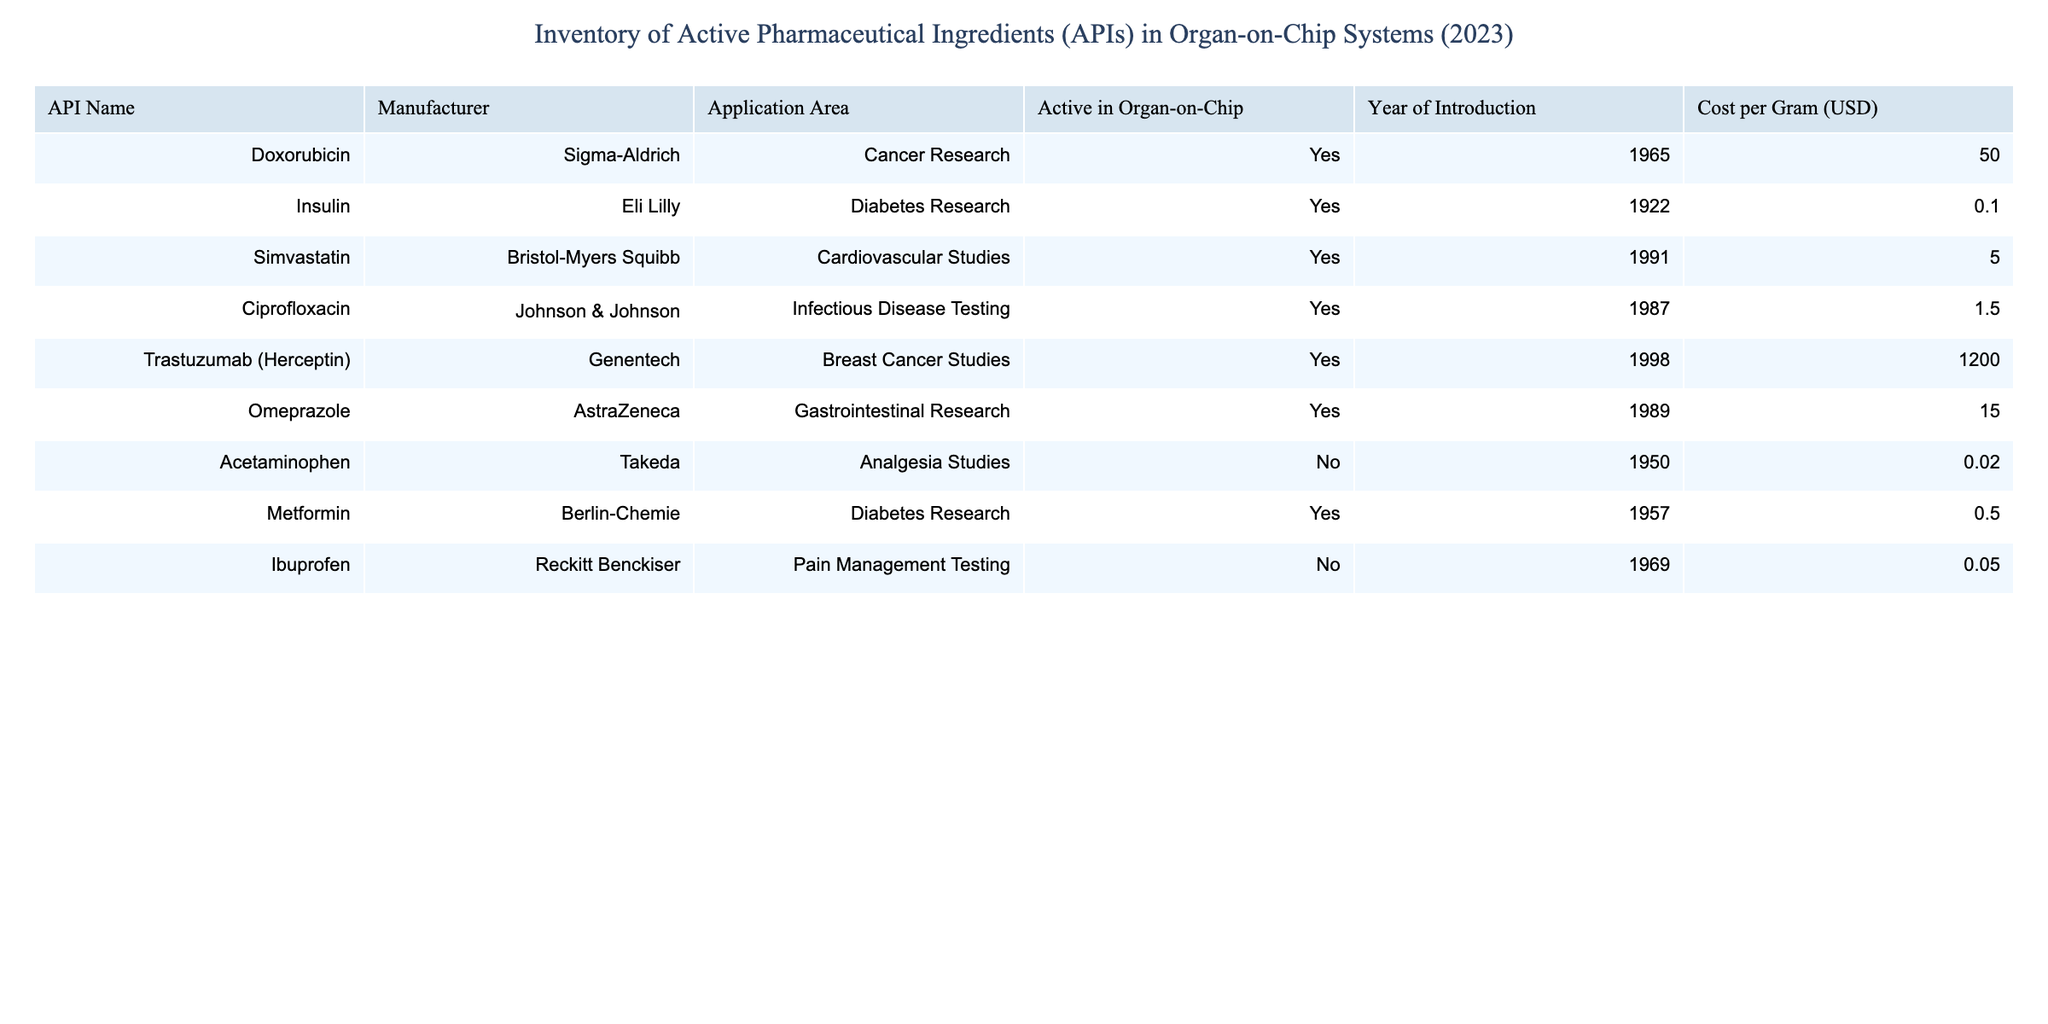What is the cost per gram of Trastuzumab (Herceptin)? The table lists Trastuzumab (Herceptin) with a specific cost per gram, which is noted as 1200.00 USD.
Answer: 1200.00 USD Which API has the lowest cost per gram? By examining the cost per gram for each API in the table, it is clear that Insulin has the lowest cost at 0.10 USD.
Answer: Insulin Are all the listed APIs active in organ-on-chip applications? By scanning the "Active in Organ-on-Chip" column, it can be seen that Acetaminophen and Ibuprofen are marked as "No."
Answer: No How many APIs listed are used for cancer research? The table shows three APIs specifically for cancer research: Doxorubicin, Trastuzumab (Herceptin), and no others. Hence, the count is 2.
Answer: 2 What is the average cost per gram of the APIs that are active in organ-on-chip? The total costs for active APIs are 50.00 + 0.10 + 5.00 + 1.50 + 1200.00 + 15.00 + 0.50 = 1272.10 USD. The number of active APIs is 6. Thus, the average cost is 1272.10/6 = 212.02 USD.
Answer: 212.02 USD Which API was introduced first and what is its cost? Looking at the "Year of Introduction" column, Insulin appears first in the list as it was introduced in 1922, and its cost per gram is 0.10 USD.
Answer: Insulin, 0.10 USD Is there an API for Diabetes Research that is not active in organ-on-chip? As per the "Active in Organ-on-Chip" column, it can be seen that Metformin is active, but there are no other diabetes APIs listed among which could potentially be inactive.
Answer: No What is the difference in cost per gram between Doxorubicin and Simvastatin? Doxorubicin is 50.00 USD and Simvastatin is 5.00 USD. The difference in cost is 50.00 - 5.00 = 45.00 USD.
Answer: 45.00 USD 